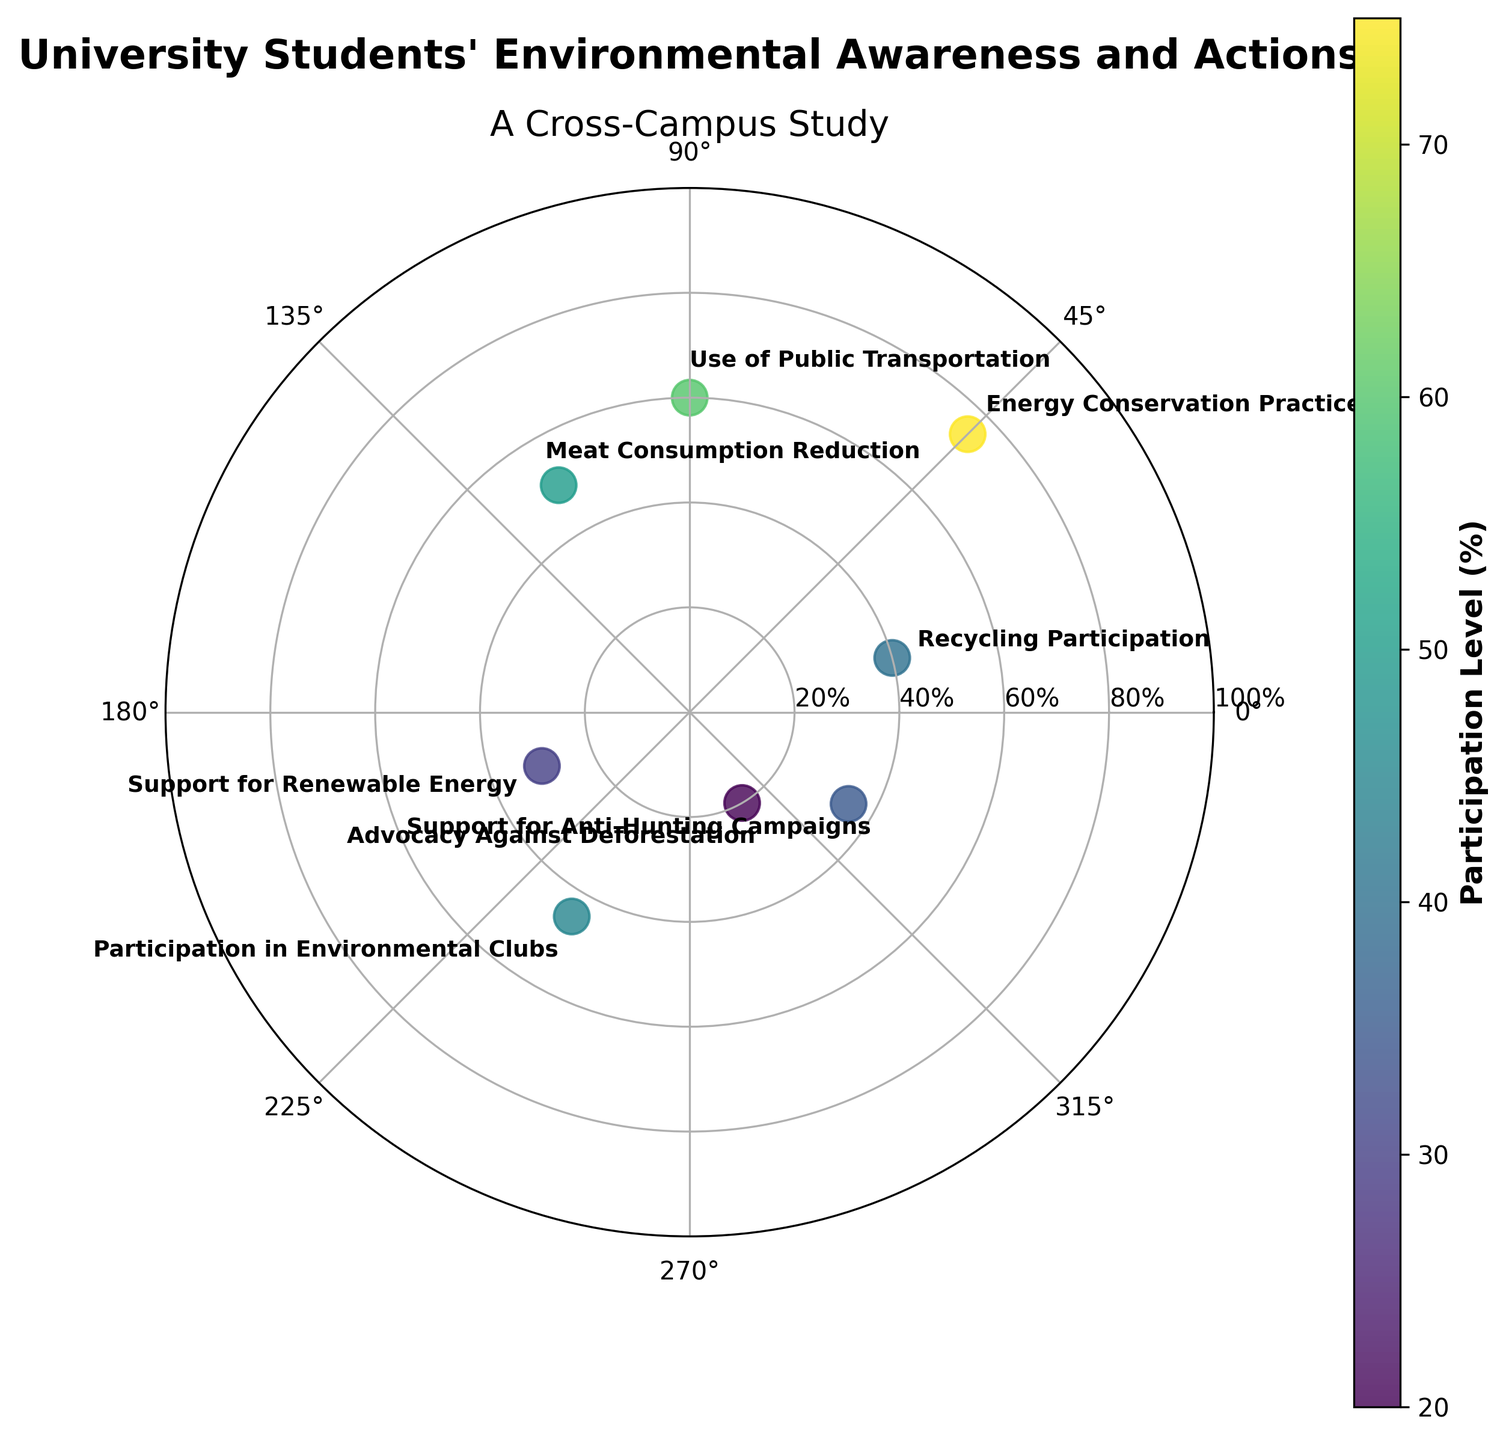What is the highest value shown in the chart? By looking at the numerical values for each label, the highest value is observed at Energy Conservation Practices with a value of 75%
Answer: 75% Which environmental action has the lowest participation level? By comparing the data points, Advocacy Against Deforestation has the lowest value of 20%
Answer: Advocacy Against Deforestation What is the range of values (difference between the highest and lowest values) represented in the chart? The highest value is 75% (Energy Conservation Practices) and the lowest is 20% (Advocacy Against Deforestation), so the range is 75% - 20% = 55%
Answer: 55% Are there more actions that have participation levels above 50% or below 50%? Actions with values above 50% are Energy Conservation Practices (75%), Use of Public Transportation (60%), Meat Consumption Reduction (50%), and Recycling Participation (40% is below 50%). Actions below 50% are Renewable Energy (30%), Environmental Clubs (45%), Anti-Hunting Campaigns (35%), and Deforestation (20%). Hence, there are 3 values above 50% and 5 values below 50%
Answer: Below How many data points represent environmental actions with participation levels between 30% and 60% inclusive? The values of interest are 40% (Recycling Participation), 45% (Participation in Environmental Clubs), 50% (Meat Consumption Reduction), 30% (Support for Renewable Energy), and 35% (Support for Anti-Hunting Campaigns). Therefore, there are 5 such data points
Answer: 5 Which environmental action is closest in value to 35%? By looking at the values, Support for Anti-Hunting Campaigns is exactly 35%
Answer: Support for Anti-Hunting Campaigns What is the average participation level for Recycling Participation and Energy Conservation Practices? The values are 40% (Recycling Participation) and 75% (Energy Conservation Practices). The average is (40% + 75%) / 2 = 115% / 2 = 57.5%
Answer: 57.5% Between which two angles do the actions with the highest and lowest participation levels lie? The highest value is 75% at 45 degrees (Energy Conservation Practices), and the lowest value is 20% at 300 degrees (Advocacy Against Deforestation)
Answer: 45 and 300 degrees 